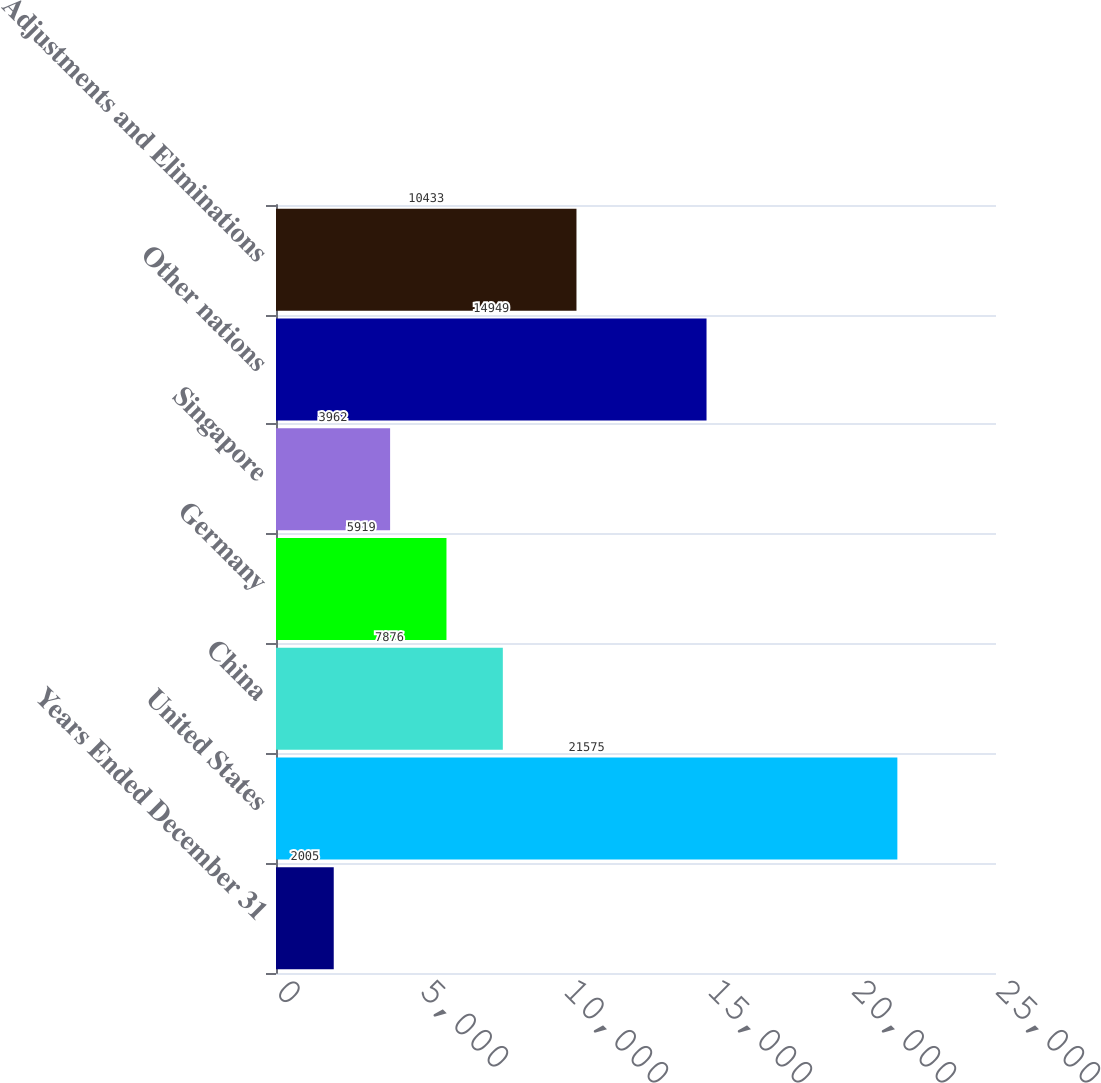Convert chart to OTSL. <chart><loc_0><loc_0><loc_500><loc_500><bar_chart><fcel>Years Ended December 31<fcel>United States<fcel>China<fcel>Germany<fcel>Singapore<fcel>Other nations<fcel>Adjustments and Eliminations<nl><fcel>2005<fcel>21575<fcel>7876<fcel>5919<fcel>3962<fcel>14949<fcel>10433<nl></chart> 